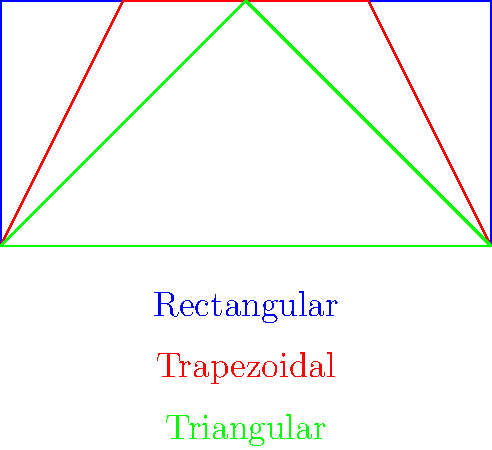As a data scientist presenting innovative methods for data visualization and predictive analytics, you are tasked with analyzing the flow characteristics in open channels with different cross-sectional shapes. Given the velocity profiles shown for rectangular, trapezoidal, and triangular channels, which shape is likely to have the highest average velocity for the same flow rate and hydraulic radius? Explain your reasoning using fluid mechanics principles and how this information could be used in predictive analytics for hydraulic engineering projects. To answer this question, we need to consider several factors:

1. Velocity distribution: The velocity profiles shown in the diagram represent the distribution of velocities across the channel cross-section. The area under these profiles represents the flow rate.

2. Wetted perimeter: This is the length of the channel cross-section in contact with the water. It affects the friction between the water and the channel walls.

3. Hydraulic radius: This is defined as the ratio of the cross-sectional area to the wetted perimeter. It's a measure of flow efficiency.

4. Manning's equation: This relates flow rate to channel characteristics:

   $$Q = \frac{1}{n} A R^{2/3} S^{1/2}$$

   Where Q is flow rate, n is Manning's roughness coefficient, A is cross-sectional area, R is hydraulic radius, and S is channel slope.

5. Continuity equation: $$Q = AV$$, where V is average velocity.

Step-by-step analysis:

1. Given the same flow rate and hydraulic radius, the cross-sectional area will be the same for all shapes (as per the continuity equation).

2. The rectangular channel has the largest wetted perimeter for a given area, followed by the trapezoidal, then the triangular.

3. With the same hydraulic radius, the triangular channel will have the smallest wetted perimeter, resulting in less friction with the channel walls.

4. Less friction means less energy loss, allowing for higher velocities in the center of the channel.

5. The velocity profile for the triangular channel shows a more pronounced parabolic shape, indicating higher maximum velocity at the center.

6. Higher maximum velocity, combined with the same cross-sectional area, results in a higher average velocity for the triangular channel.

In predictive analytics for hydraulic engineering:

1. This information can be used to develop models predicting flow characteristics based on channel shape.
2. Machine learning algorithms could be trained on this data to optimize channel design for specific flow requirements.
3. Data visualization techniques could be employed to illustrate the relationship between channel shape and flow efficiency, aiding in decision-making processes for infrastructure projects.
Answer: Triangular channel; least wetted perimeter, reduced friction, higher center velocity. 